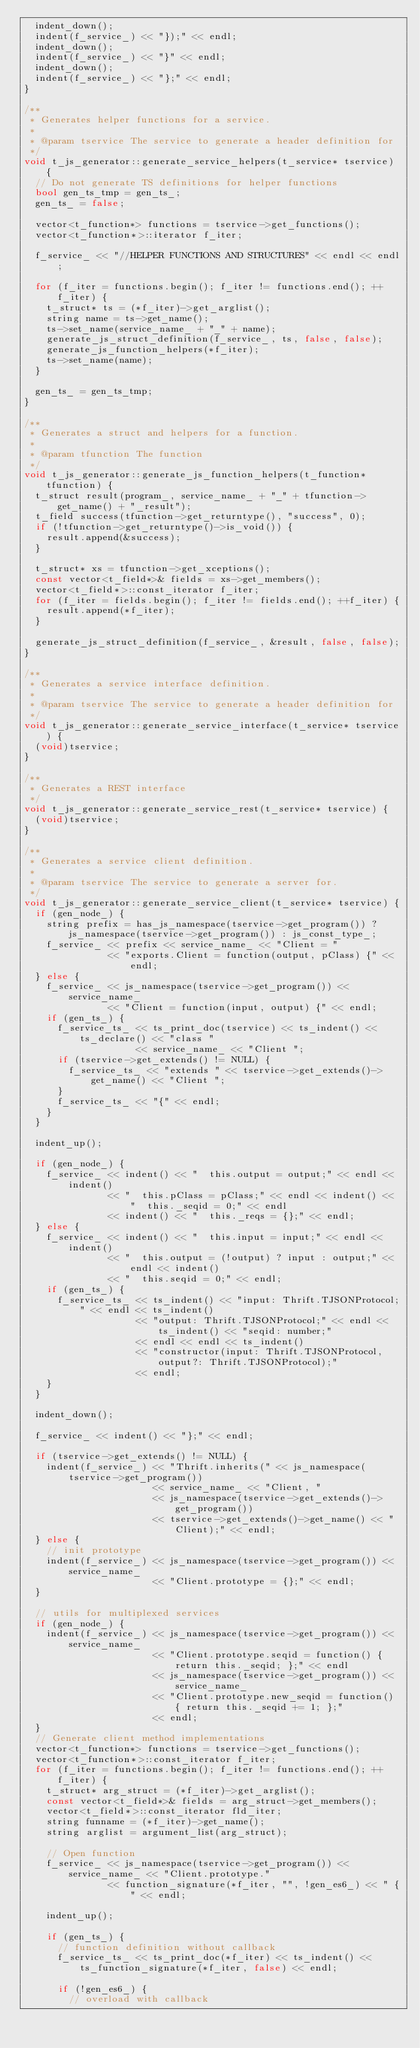<code> <loc_0><loc_0><loc_500><loc_500><_C++_>  indent_down();
  indent(f_service_) << "});" << endl;
  indent_down();
  indent(f_service_) << "}" << endl;
  indent_down();
  indent(f_service_) << "};" << endl;
}

/**
 * Generates helper functions for a service.
 *
 * @param tservice The service to generate a header definition for
 */
void t_js_generator::generate_service_helpers(t_service* tservice) {
  // Do not generate TS definitions for helper functions
  bool gen_ts_tmp = gen_ts_;
  gen_ts_ = false;

  vector<t_function*> functions = tservice->get_functions();
  vector<t_function*>::iterator f_iter;

  f_service_ << "//HELPER FUNCTIONS AND STRUCTURES" << endl << endl;

  for (f_iter = functions.begin(); f_iter != functions.end(); ++f_iter) {
    t_struct* ts = (*f_iter)->get_arglist();
    string name = ts->get_name();
    ts->set_name(service_name_ + "_" + name);
    generate_js_struct_definition(f_service_, ts, false, false);
    generate_js_function_helpers(*f_iter);
    ts->set_name(name);
  }

  gen_ts_ = gen_ts_tmp;
}

/**
 * Generates a struct and helpers for a function.
 *
 * @param tfunction The function
 */
void t_js_generator::generate_js_function_helpers(t_function* tfunction) {
  t_struct result(program_, service_name_ + "_" + tfunction->get_name() + "_result");
  t_field success(tfunction->get_returntype(), "success", 0);
  if (!tfunction->get_returntype()->is_void()) {
    result.append(&success);
  }

  t_struct* xs = tfunction->get_xceptions();
  const vector<t_field*>& fields = xs->get_members();
  vector<t_field*>::const_iterator f_iter;
  for (f_iter = fields.begin(); f_iter != fields.end(); ++f_iter) {
    result.append(*f_iter);
  }

  generate_js_struct_definition(f_service_, &result, false, false);
}

/**
 * Generates a service interface definition.
 *
 * @param tservice The service to generate a header definition for
 */
void t_js_generator::generate_service_interface(t_service* tservice) {
  (void)tservice;
}

/**
 * Generates a REST interface
 */
void t_js_generator::generate_service_rest(t_service* tservice) {
  (void)tservice;
}

/**
 * Generates a service client definition.
 *
 * @param tservice The service to generate a server for.
 */
void t_js_generator::generate_service_client(t_service* tservice) {
  if (gen_node_) {
    string prefix = has_js_namespace(tservice->get_program()) ? js_namespace(tservice->get_program()) : js_const_type_;
    f_service_ << prefix << service_name_ << "Client = "
               << "exports.Client = function(output, pClass) {" << endl;
  } else {
    f_service_ << js_namespace(tservice->get_program()) << service_name_
               << "Client = function(input, output) {" << endl;
    if (gen_ts_) {
      f_service_ts_ << ts_print_doc(tservice) << ts_indent() << ts_declare() << "class "
                    << service_name_ << "Client ";
      if (tservice->get_extends() != NULL) {
        f_service_ts_ << "extends " << tservice->get_extends()->get_name() << "Client ";
      }
      f_service_ts_ << "{" << endl;
    }
  }

  indent_up();

  if (gen_node_) {
    f_service_ << indent() << "  this.output = output;" << endl << indent()
               << "  this.pClass = pClass;" << endl << indent() << "  this._seqid = 0;" << endl
               << indent() << "  this._reqs = {};" << endl;
  } else {
    f_service_ << indent() << "  this.input = input;" << endl << indent()
               << "  this.output = (!output) ? input : output;" << endl << indent()
               << "  this.seqid = 0;" << endl;
    if (gen_ts_) {
      f_service_ts_ << ts_indent() << "input: Thrift.TJSONProtocol;" << endl << ts_indent()
                    << "output: Thrift.TJSONProtocol;" << endl << ts_indent() << "seqid: number;"
                    << endl << endl << ts_indent()
                    << "constructor(input: Thrift.TJSONProtocol, output?: Thrift.TJSONProtocol);"
                    << endl;
    }
  }

  indent_down();

  f_service_ << indent() << "};" << endl;

  if (tservice->get_extends() != NULL) {
    indent(f_service_) << "Thrift.inherits(" << js_namespace(tservice->get_program())
                       << service_name_ << "Client, "
                       << js_namespace(tservice->get_extends()->get_program())
                       << tservice->get_extends()->get_name() << "Client);" << endl;
  } else {
    // init prototype
    indent(f_service_) << js_namespace(tservice->get_program()) << service_name_
                       << "Client.prototype = {};" << endl;
  }

  // utils for multiplexed services
  if (gen_node_) {
    indent(f_service_) << js_namespace(tservice->get_program()) << service_name_
                       << "Client.prototype.seqid = function() { return this._seqid; };" << endl
                       << js_namespace(tservice->get_program()) << service_name_
                       << "Client.prototype.new_seqid = function() { return this._seqid += 1; };"
                       << endl;
  }
  // Generate client method implementations
  vector<t_function*> functions = tservice->get_functions();
  vector<t_function*>::const_iterator f_iter;
  for (f_iter = functions.begin(); f_iter != functions.end(); ++f_iter) {
    t_struct* arg_struct = (*f_iter)->get_arglist();
    const vector<t_field*>& fields = arg_struct->get_members();
    vector<t_field*>::const_iterator fld_iter;
    string funname = (*f_iter)->get_name();
    string arglist = argument_list(arg_struct);

    // Open function
    f_service_ << js_namespace(tservice->get_program()) << service_name_ << "Client.prototype."
               << function_signature(*f_iter, "", !gen_es6_) << " {" << endl;

    indent_up();

    if (gen_ts_) {
      // function definition without callback
      f_service_ts_ << ts_print_doc(*f_iter) << ts_indent() << ts_function_signature(*f_iter, false) << endl;

      if (!gen_es6_) {
        // overload with callback</code> 